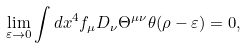<formula> <loc_0><loc_0><loc_500><loc_500>\lim _ { \varepsilon \to 0 } \int d x ^ { 4 } f _ { \mu } D _ { \nu } \Theta ^ { \mu \nu } \theta ( \rho - \varepsilon ) = 0 ,</formula> 